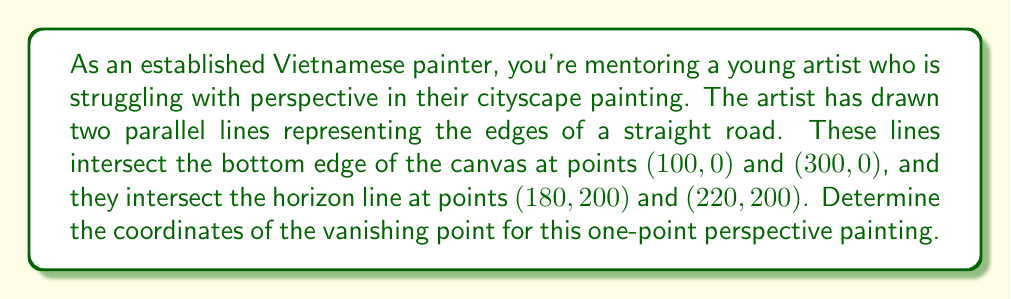Provide a solution to this math problem. Let's approach this step-by-step:

1) In a one-point perspective, parallel lines converge at a single vanishing point on the horizon line. This point is where the road edges meet.

2) We can find this point by determining the equations of the two lines representing the road edges and finding their intersection.

3) For the left edge of the road:
   Point 1: (100, 0)
   Point 2: (180, 200)
   
   Slope = $m_1 = \frac{200 - 0}{180 - 100} = \frac{25}{10} = 2.5$
   
   Equation: $y = 2.5x - 250$

4) For the right edge of the road:
   Point 1: (300, 0)
   Point 2: (220, 200)
   
   Slope = $m_2 = \frac{200 - 0}{220 - 300} = \frac{-25}{10} = -2.5$
   
   Equation: $y = -2.5x + 750$

5) The vanishing point is where these lines intersect. To find this, we set the equations equal:

   $2.5x - 250 = -2.5x + 750$
   
   $5x = 1000$
   
   $x = 200$

6) To find y, we can substitute this x-value into either equation:

   $y = 2.5(200) - 250 = 250$

Therefore, the vanishing point is at (200, 250).

7) We can verify this is correct because:
   - The x-coordinate (200) is halfway between 180 and 220, which are the x-coordinates where the road edges meet the horizon.
   - The y-coordinate (250) is above the horizon line (y = 200), which is typical for elevated viewpoints in cityscape paintings.
Answer: The coordinates of the vanishing point are (200, 250). 